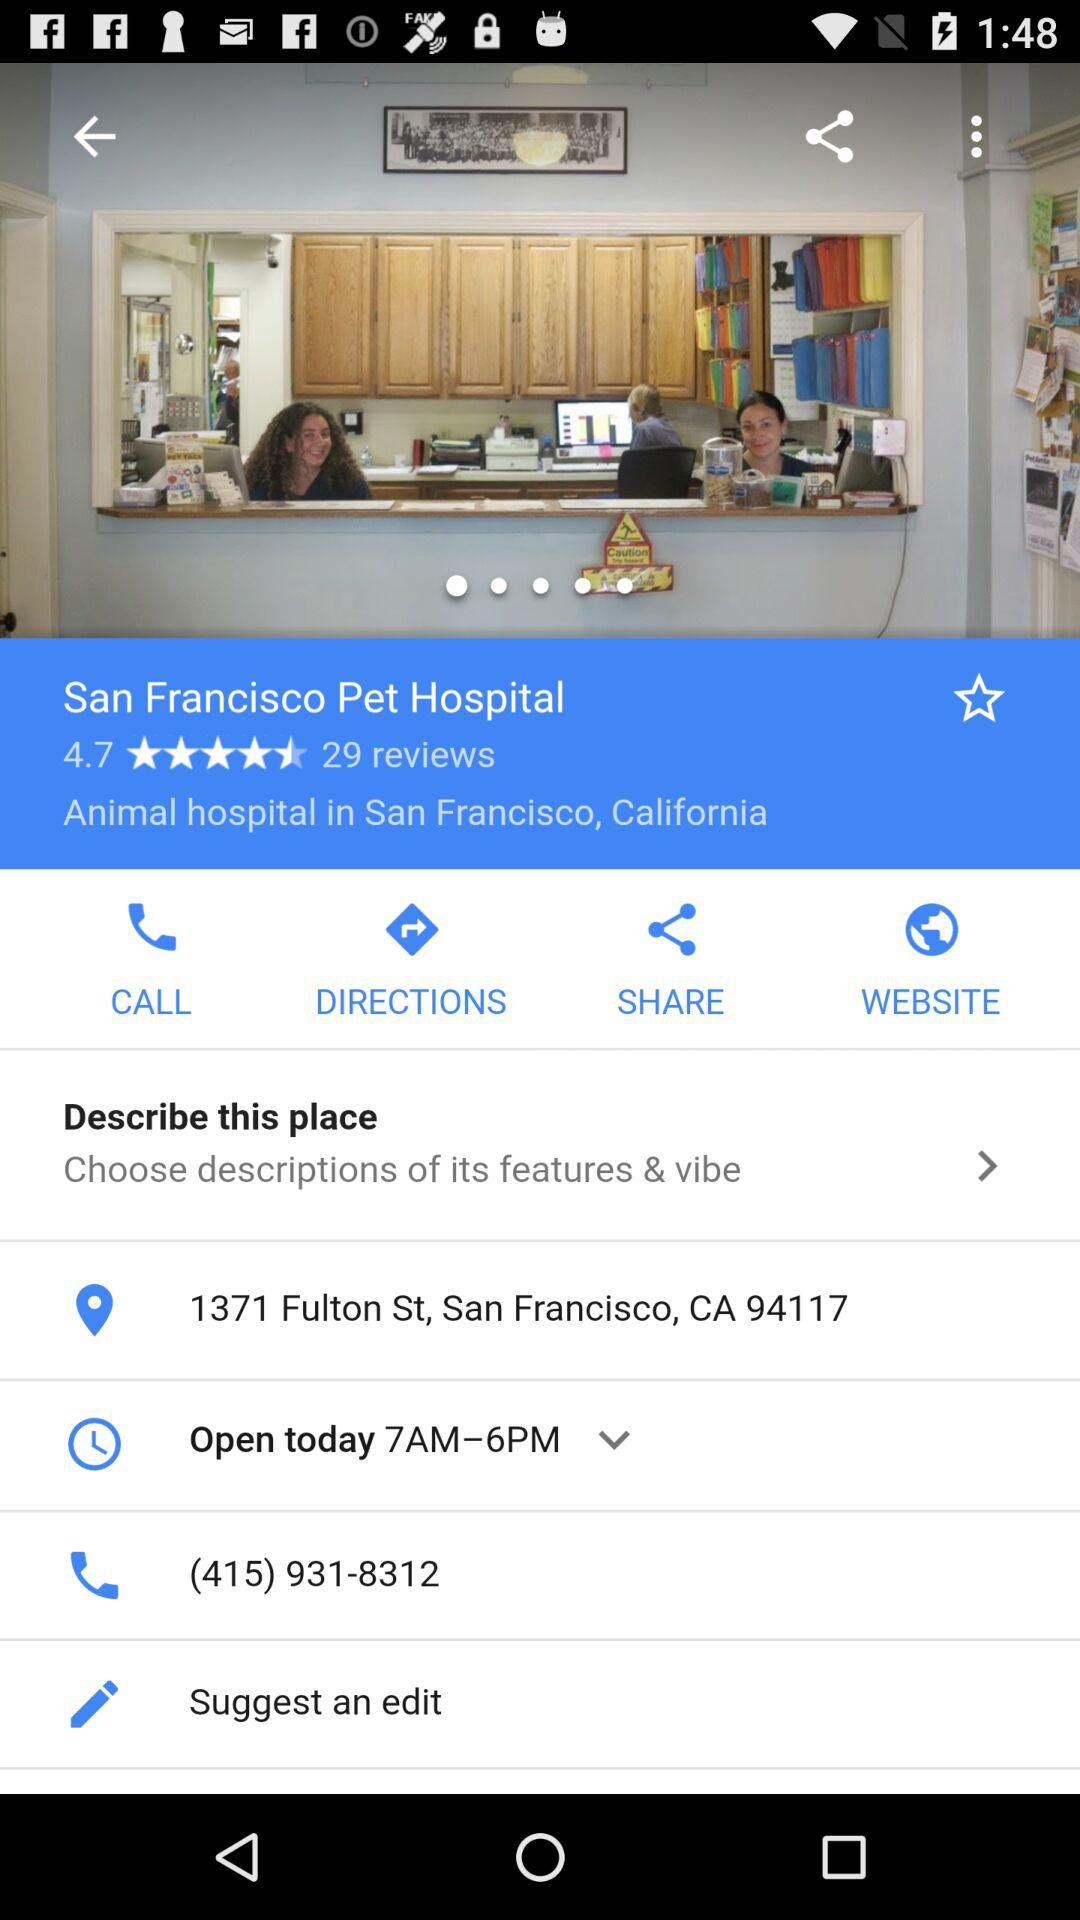What is the phone number? The phone number is (415) 931-8312. 